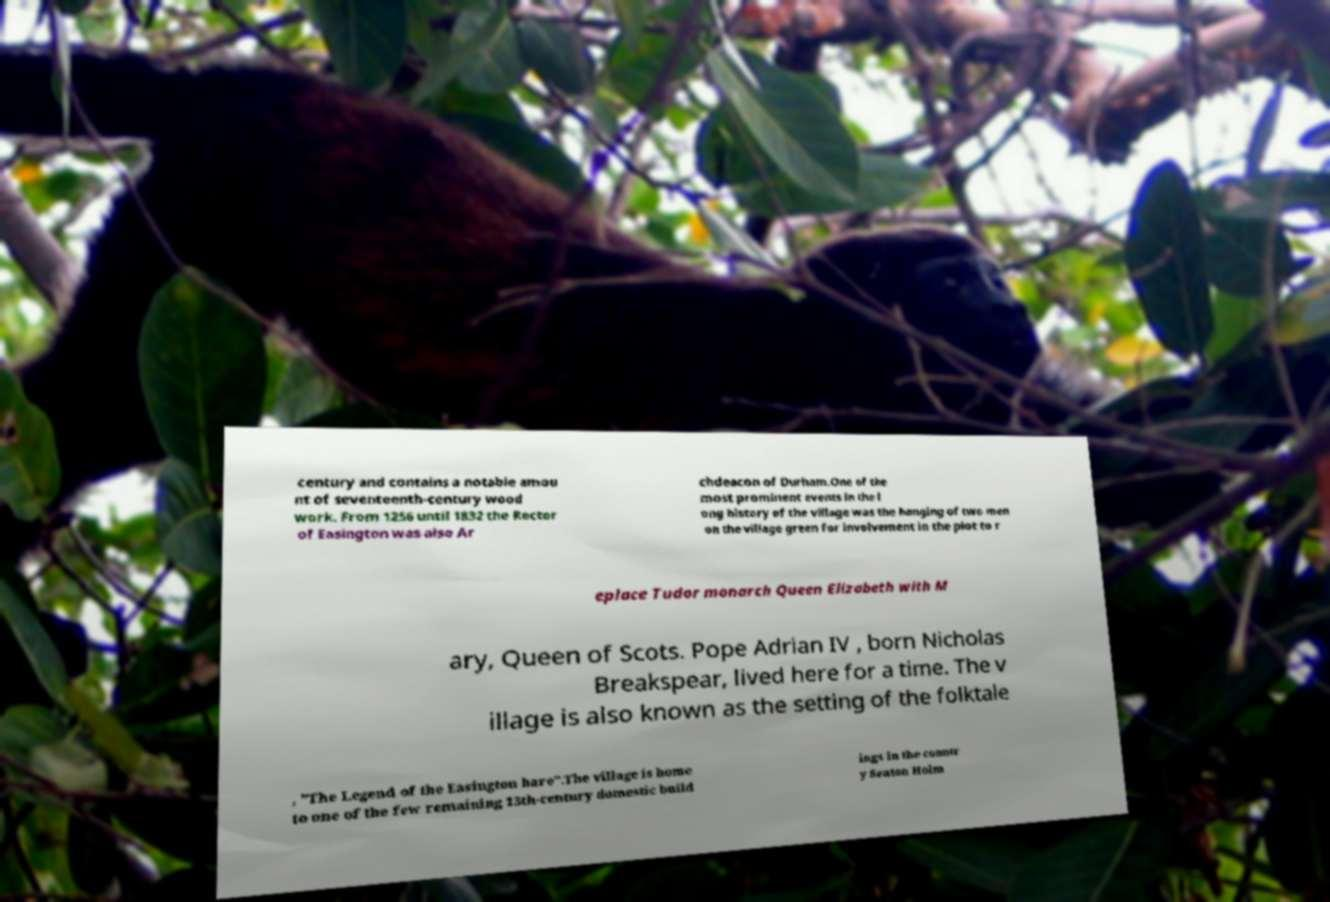Could you assist in decoding the text presented in this image and type it out clearly? century and contains a notable amou nt of seventeenth-century wood work. From 1256 until 1832 the Rector of Easington was also Ar chdeacon of Durham.One of the most prominent events in the l ong history of the village was the hanging of two men on the village green for involvement in the plot to r eplace Tudor monarch Queen Elizabeth with M ary, Queen of Scots. Pope Adrian IV , born Nicholas Breakspear, lived here for a time. The v illage is also known as the setting of the folktale , "The Legend of the Easington hare".The village is home to one of the few remaining 13th-century domestic build ings in the countr y Seaton Holm 